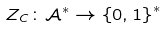<formula> <loc_0><loc_0><loc_500><loc_500>Z _ { C } \colon \mathcal { A } ^ { \ast } \rightarrow \left \{ 0 , 1 \right \} ^ { \ast }</formula> 